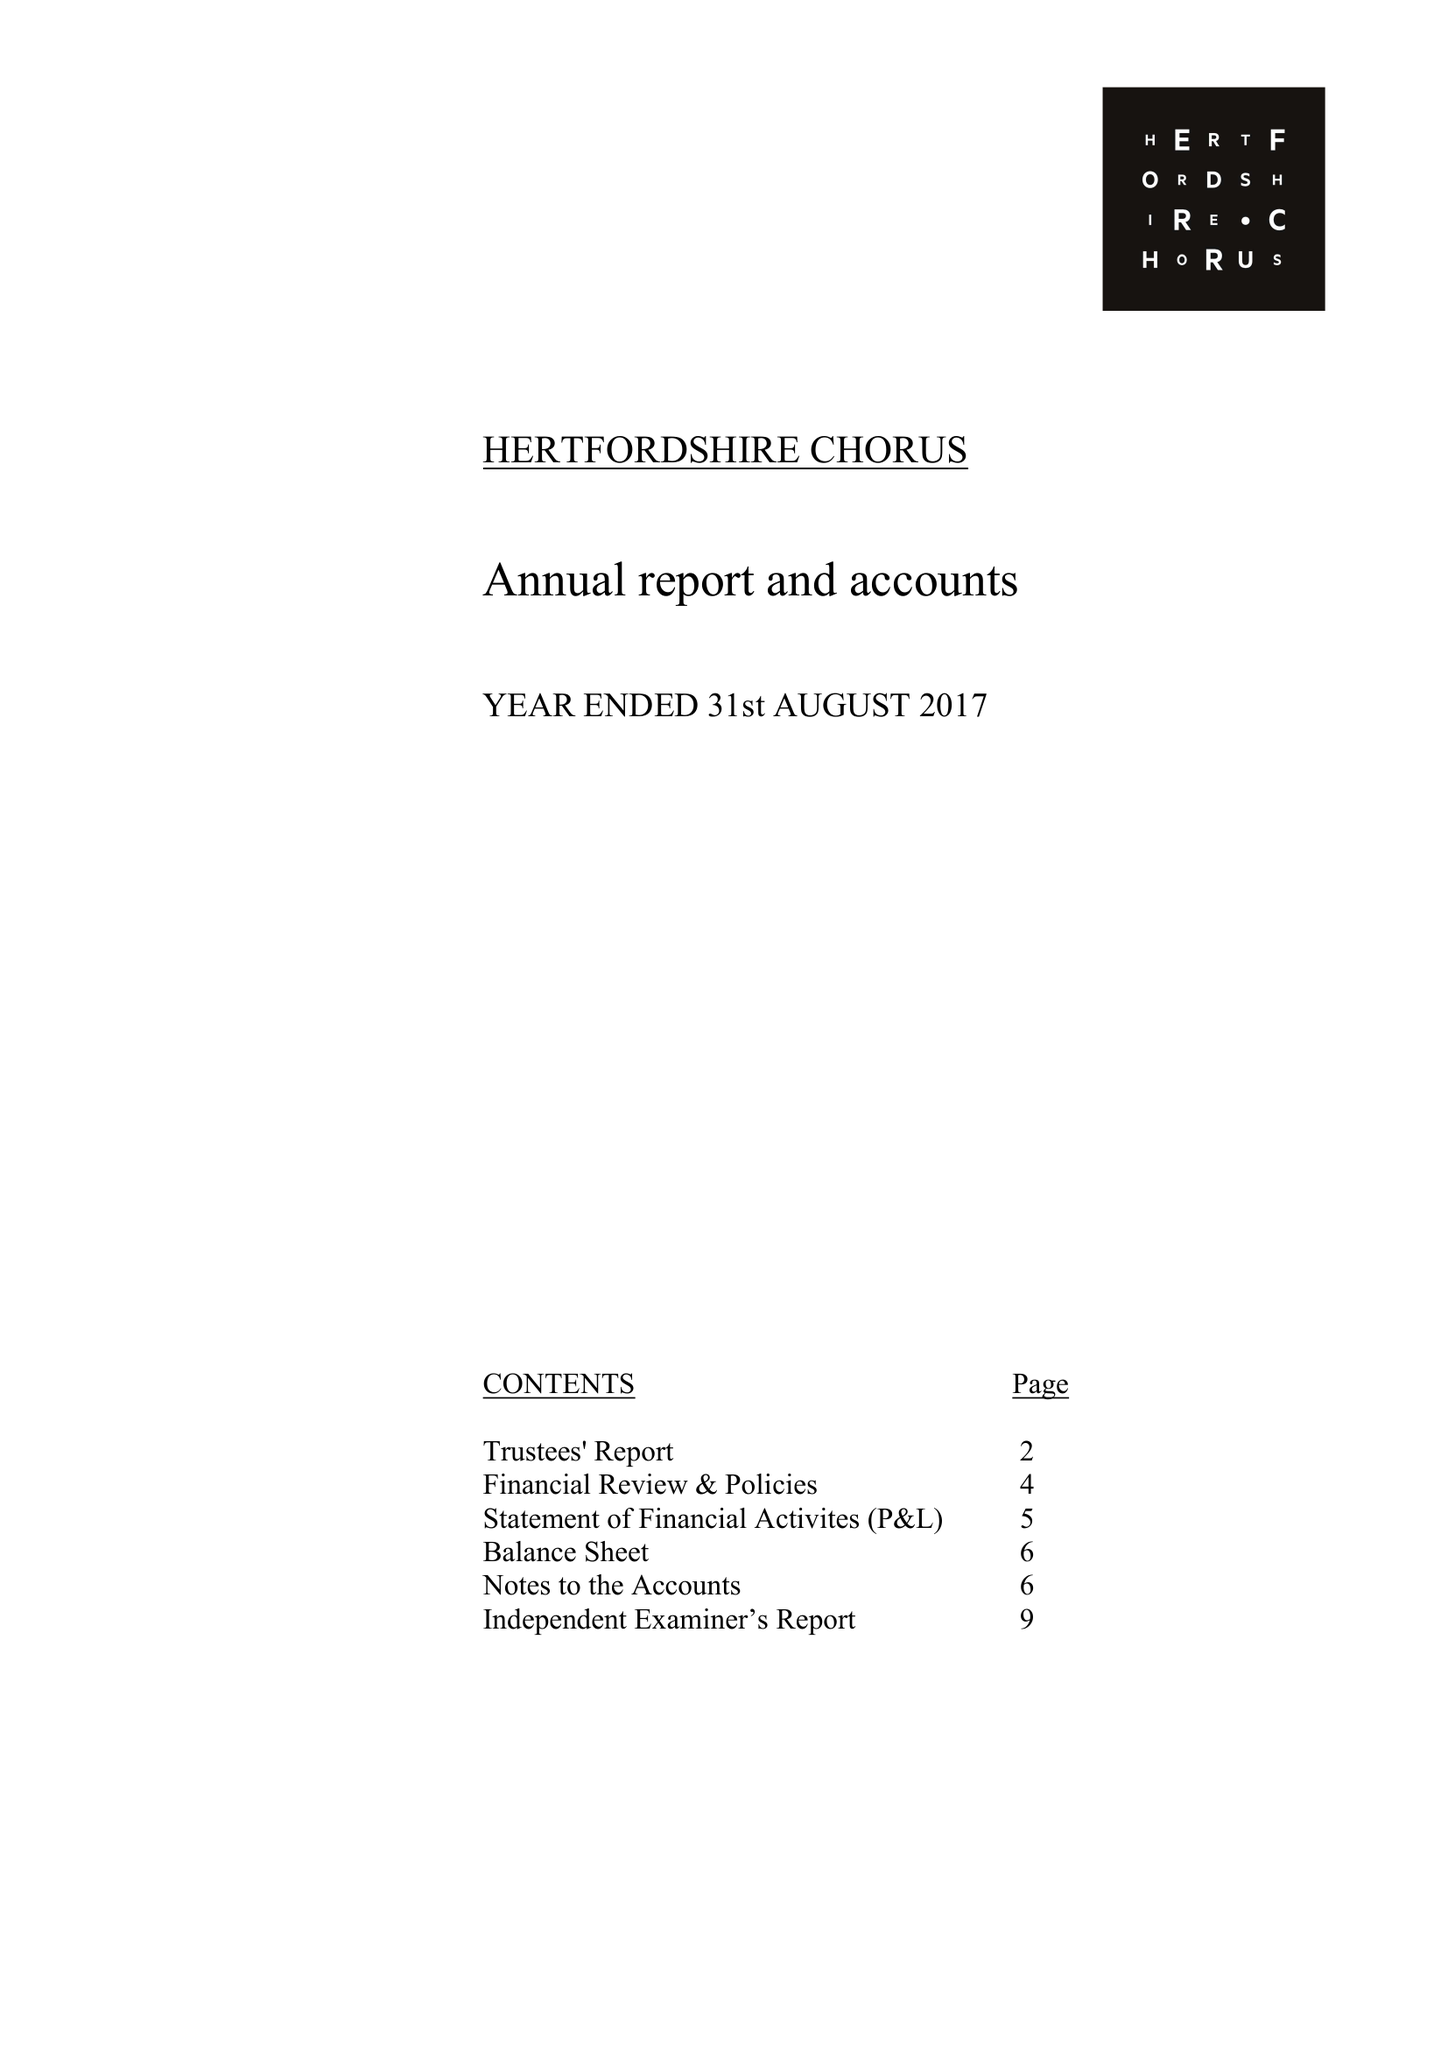What is the value for the address__postcode?
Answer the question using a single word or phrase. AL1 5QZ 